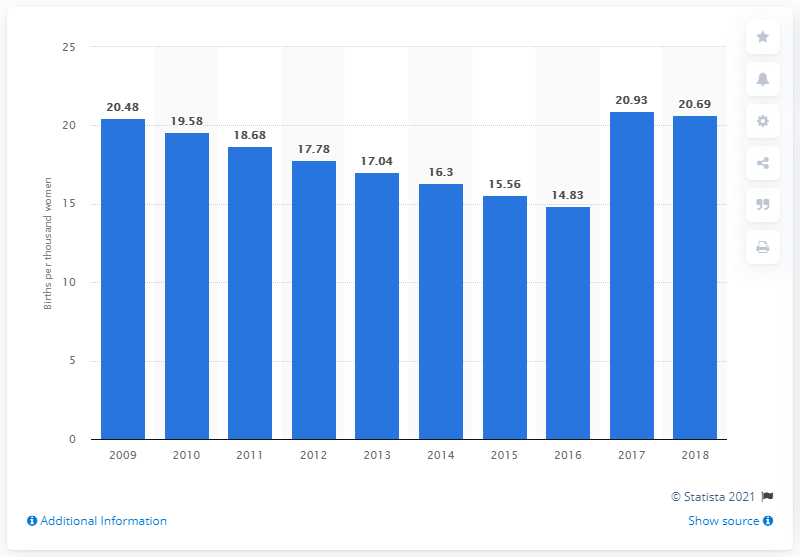Mention a couple of crucial points in this snapshot. In 2016, there were approximately 15 births per thousand women aged between 15 and 19 years old in Sri Lanka. 